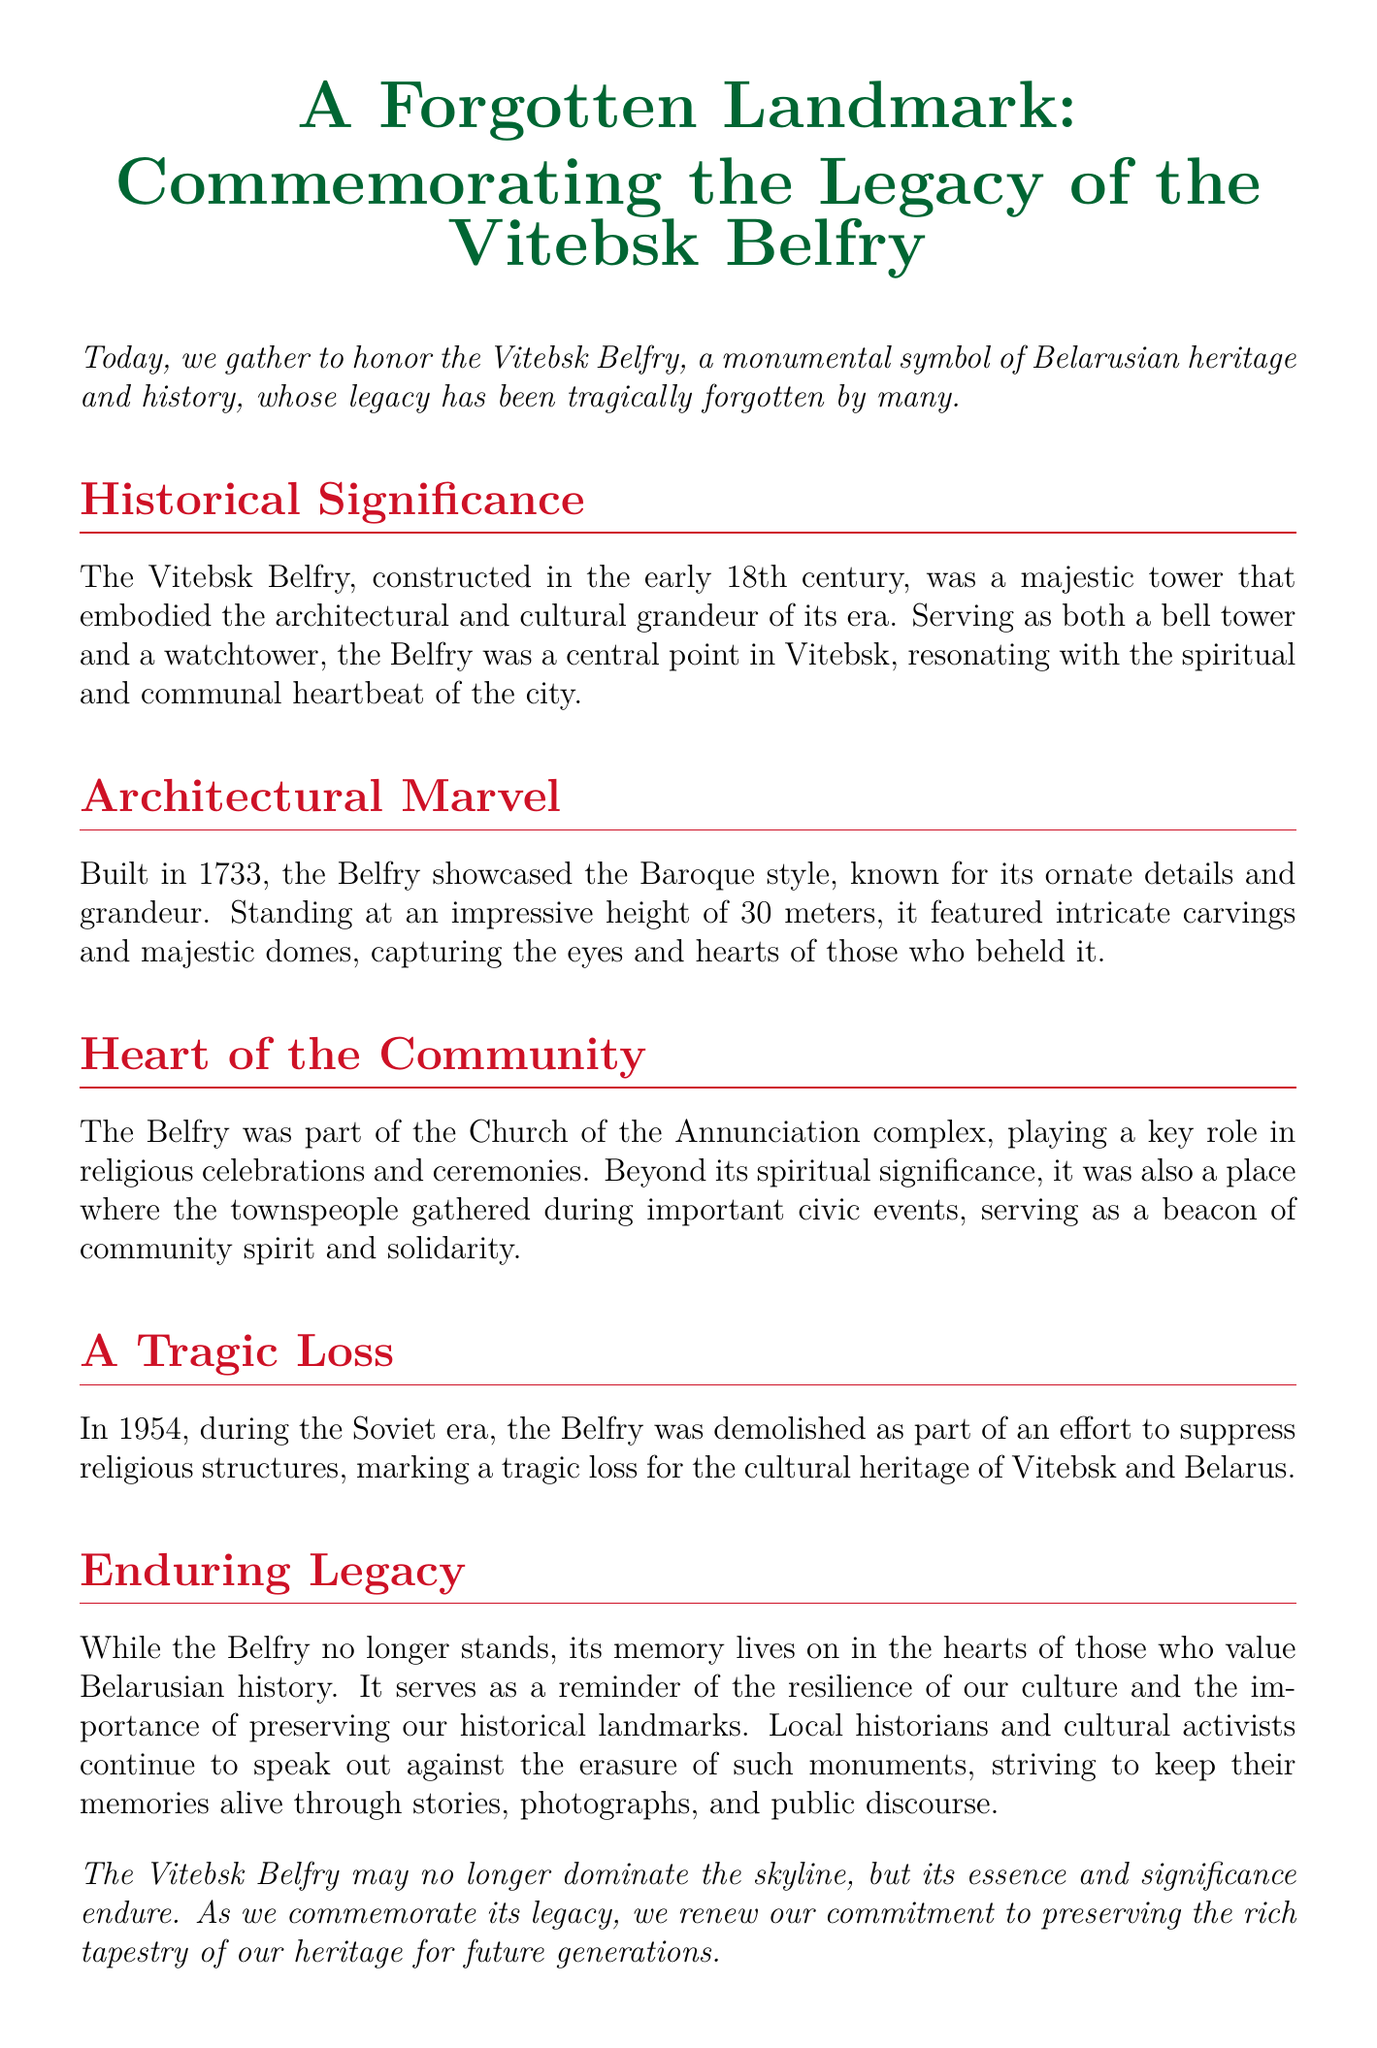What year was the Vitebsk Belfry constructed? The document states that the Vitebsk Belfry was constructed in the early 18th century, specifically mentioning it was built in 1733.
Answer: 1733 What style of architecture did the Belfry showcase? The document explicitly identifies the architectural style of the Belfry as Baroque.
Answer: Baroque How tall was the Vitebsk Belfry? The document notes that the Belfry stood at an impressive height of 30 meters.
Answer: 30 meters In what year was the Belfry demolished? According to the document, the Belfry was demolished in 1954.
Answer: 1954 What role did the Belfry play in the community? The document describes the Belfry as a place for religious celebrations and civic events, highlighting its role in community spirit.
Answer: Community spirit What was the primary function of the Vitebsk Belfry? The document states that the Belfry served as both a bell tower and a watchtower.
Answer: Bell tower and watchtower What significant action took place during the Soviet era regarding the Belfry? The document states that the Belfry was demolished as part of an effort to suppress religious structures during the Soviet era.
Answer: Demolished What does the document emphasize about preserving historical landmarks? The document emphasizes the importance of preserving historical landmarks for future generations and the resilience of culture.
Answer: Preserving historical landmarks What is the document's overall tone regarding the Vitebsk Belfry? The tone of the document is commemorative and mournful, as it honors the legacy of the Belfry while expressing sadness over its loss.
Answer: Commemorative and mournful 